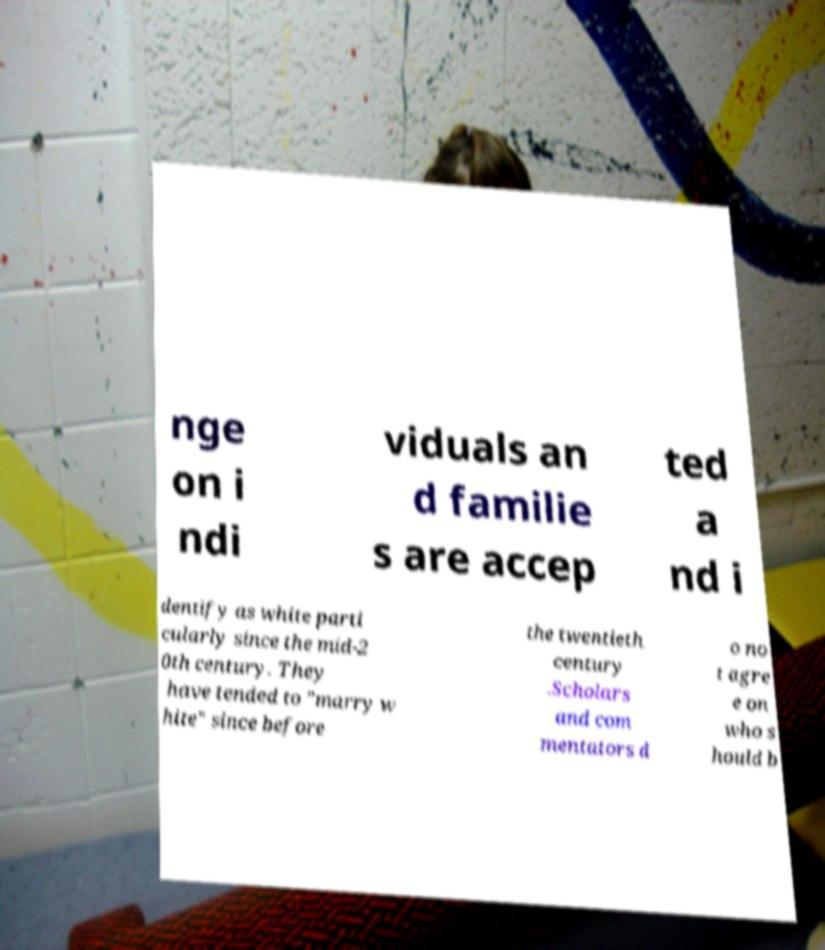Can you accurately transcribe the text from the provided image for me? nge on i ndi viduals an d familie s are accep ted a nd i dentify as white parti cularly since the mid-2 0th century. They have tended to "marry w hite" since before the twentieth century .Scholars and com mentators d o no t agre e on who s hould b 